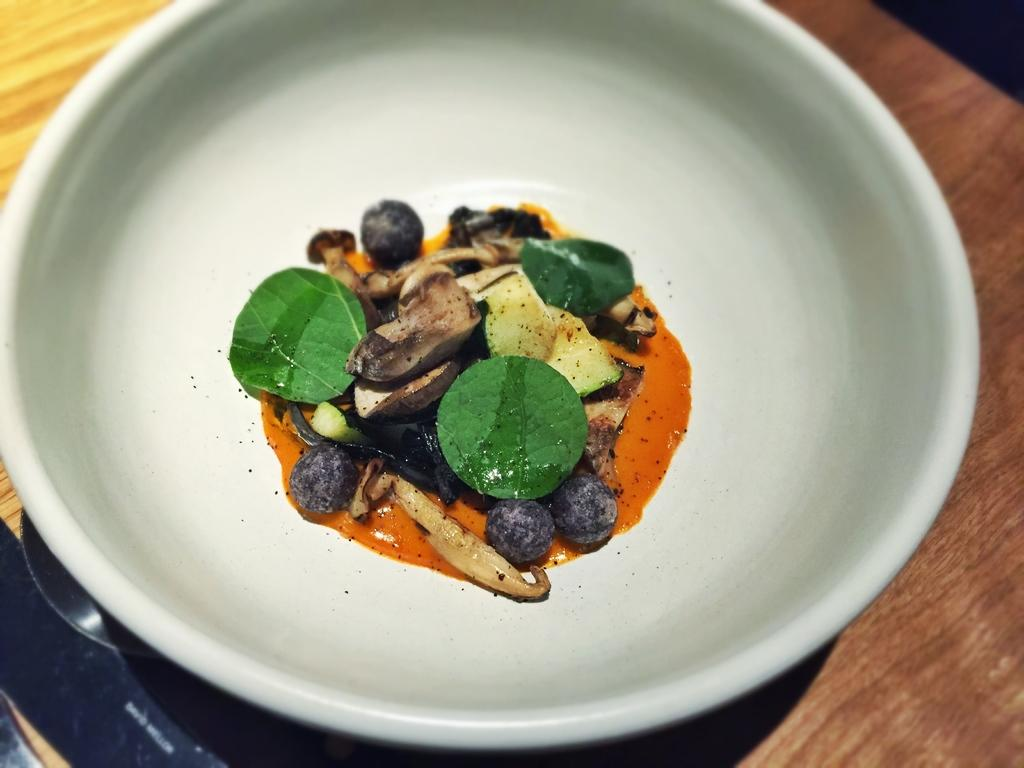What is the main subject of the image? There is a food item on a plate in the image. Can you describe the setting of the image? There is a table in the background of the image. What type of bat can be seen flying around the food item in the image? There is no bat present in the image; it only features a food item on a plate and a table in the background. 